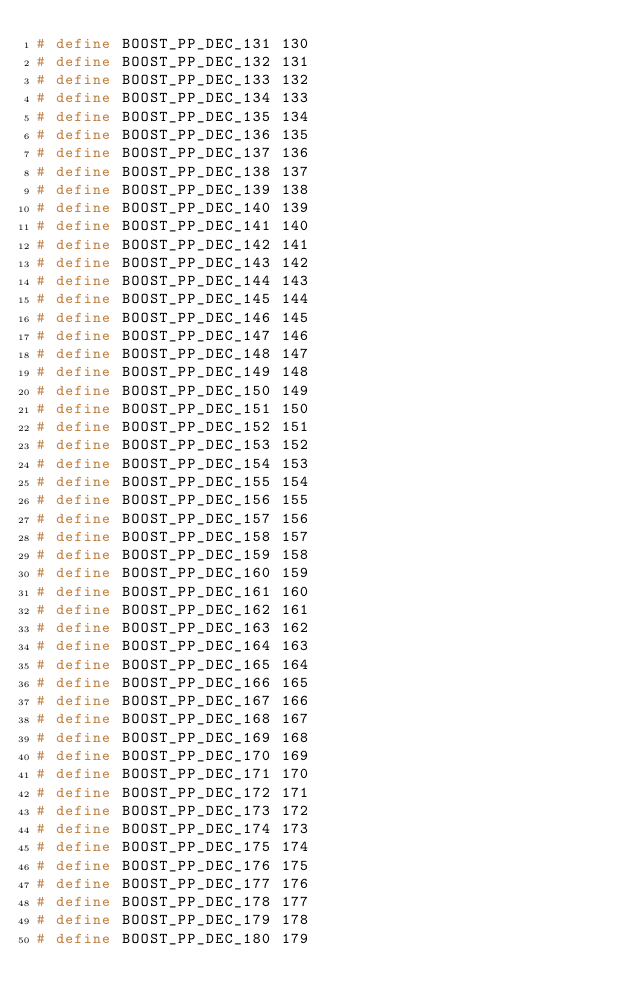<code> <loc_0><loc_0><loc_500><loc_500><_C++_># define BOOST_PP_DEC_131 130
# define BOOST_PP_DEC_132 131
# define BOOST_PP_DEC_133 132
# define BOOST_PP_DEC_134 133
# define BOOST_PP_DEC_135 134
# define BOOST_PP_DEC_136 135
# define BOOST_PP_DEC_137 136
# define BOOST_PP_DEC_138 137
# define BOOST_PP_DEC_139 138
# define BOOST_PP_DEC_140 139
# define BOOST_PP_DEC_141 140
# define BOOST_PP_DEC_142 141
# define BOOST_PP_DEC_143 142
# define BOOST_PP_DEC_144 143
# define BOOST_PP_DEC_145 144
# define BOOST_PP_DEC_146 145
# define BOOST_PP_DEC_147 146
# define BOOST_PP_DEC_148 147
# define BOOST_PP_DEC_149 148
# define BOOST_PP_DEC_150 149
# define BOOST_PP_DEC_151 150
# define BOOST_PP_DEC_152 151
# define BOOST_PP_DEC_153 152
# define BOOST_PP_DEC_154 153
# define BOOST_PP_DEC_155 154
# define BOOST_PP_DEC_156 155
# define BOOST_PP_DEC_157 156
# define BOOST_PP_DEC_158 157
# define BOOST_PP_DEC_159 158
# define BOOST_PP_DEC_160 159
# define BOOST_PP_DEC_161 160
# define BOOST_PP_DEC_162 161
# define BOOST_PP_DEC_163 162
# define BOOST_PP_DEC_164 163
# define BOOST_PP_DEC_165 164
# define BOOST_PP_DEC_166 165
# define BOOST_PP_DEC_167 166
# define BOOST_PP_DEC_168 167
# define BOOST_PP_DEC_169 168
# define BOOST_PP_DEC_170 169
# define BOOST_PP_DEC_171 170
# define BOOST_PP_DEC_172 171
# define BOOST_PP_DEC_173 172
# define BOOST_PP_DEC_174 173
# define BOOST_PP_DEC_175 174
# define BOOST_PP_DEC_176 175
# define BOOST_PP_DEC_177 176
# define BOOST_PP_DEC_178 177
# define BOOST_PP_DEC_179 178
# define BOOST_PP_DEC_180 179</code> 